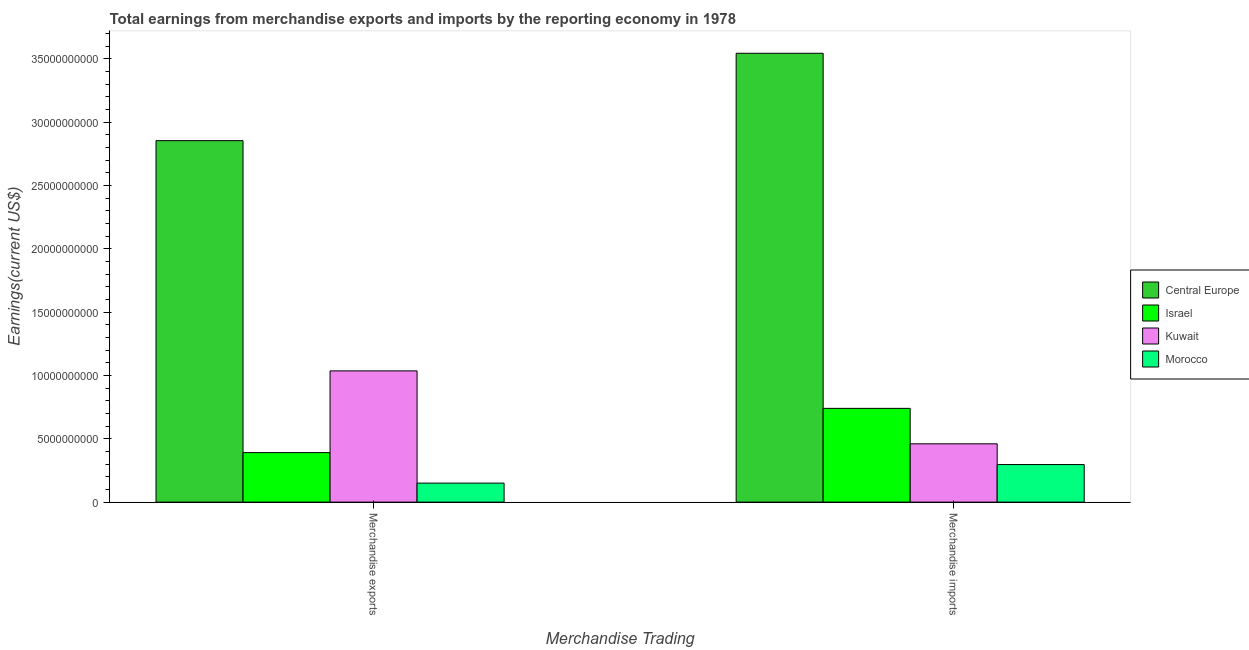What is the label of the 2nd group of bars from the left?
Your answer should be very brief. Merchandise imports. What is the earnings from merchandise exports in Morocco?
Your answer should be compact. 1.50e+09. Across all countries, what is the maximum earnings from merchandise imports?
Your response must be concise. 3.54e+1. Across all countries, what is the minimum earnings from merchandise imports?
Offer a very short reply. 2.97e+09. In which country was the earnings from merchandise exports maximum?
Make the answer very short. Central Europe. In which country was the earnings from merchandise imports minimum?
Ensure brevity in your answer.  Morocco. What is the total earnings from merchandise exports in the graph?
Your answer should be compact. 4.43e+1. What is the difference between the earnings from merchandise imports in Morocco and that in Kuwait?
Provide a succinct answer. -1.64e+09. What is the difference between the earnings from merchandise exports in Israel and the earnings from merchandise imports in Morocco?
Provide a short and direct response. 9.44e+08. What is the average earnings from merchandise imports per country?
Keep it short and to the point. 1.26e+1. What is the difference between the earnings from merchandise imports and earnings from merchandise exports in Israel?
Keep it short and to the point. 3.49e+09. What is the ratio of the earnings from merchandise exports in Israel to that in Kuwait?
Offer a terse response. 0.38. Is the earnings from merchandise exports in Israel less than that in Morocco?
Ensure brevity in your answer.  No. What does the 1st bar from the left in Merchandise imports represents?
Your answer should be very brief. Central Europe. What does the 2nd bar from the right in Merchandise exports represents?
Your answer should be compact. Kuwait. How many bars are there?
Your response must be concise. 8. How many countries are there in the graph?
Provide a short and direct response. 4. What is the difference between two consecutive major ticks on the Y-axis?
Provide a succinct answer. 5.00e+09. Are the values on the major ticks of Y-axis written in scientific E-notation?
Provide a short and direct response. No. Where does the legend appear in the graph?
Give a very brief answer. Center right. How many legend labels are there?
Make the answer very short. 4. What is the title of the graph?
Offer a very short reply. Total earnings from merchandise exports and imports by the reporting economy in 1978. Does "Ireland" appear as one of the legend labels in the graph?
Your answer should be very brief. No. What is the label or title of the X-axis?
Keep it short and to the point. Merchandise Trading. What is the label or title of the Y-axis?
Offer a very short reply. Earnings(current US$). What is the Earnings(current US$) in Central Europe in Merchandise exports?
Make the answer very short. 2.85e+1. What is the Earnings(current US$) of Israel in Merchandise exports?
Your response must be concise. 3.91e+09. What is the Earnings(current US$) of Kuwait in Merchandise exports?
Your response must be concise. 1.04e+1. What is the Earnings(current US$) of Morocco in Merchandise exports?
Your answer should be very brief. 1.50e+09. What is the Earnings(current US$) of Central Europe in Merchandise imports?
Your answer should be compact. 3.54e+1. What is the Earnings(current US$) of Israel in Merchandise imports?
Offer a terse response. 7.40e+09. What is the Earnings(current US$) of Kuwait in Merchandise imports?
Give a very brief answer. 4.60e+09. What is the Earnings(current US$) of Morocco in Merchandise imports?
Give a very brief answer. 2.97e+09. Across all Merchandise Trading, what is the maximum Earnings(current US$) in Central Europe?
Your answer should be compact. 3.54e+1. Across all Merchandise Trading, what is the maximum Earnings(current US$) of Israel?
Offer a terse response. 7.40e+09. Across all Merchandise Trading, what is the maximum Earnings(current US$) in Kuwait?
Your response must be concise. 1.04e+1. Across all Merchandise Trading, what is the maximum Earnings(current US$) of Morocco?
Your response must be concise. 2.97e+09. Across all Merchandise Trading, what is the minimum Earnings(current US$) in Central Europe?
Your answer should be compact. 2.85e+1. Across all Merchandise Trading, what is the minimum Earnings(current US$) in Israel?
Give a very brief answer. 3.91e+09. Across all Merchandise Trading, what is the minimum Earnings(current US$) in Kuwait?
Provide a short and direct response. 4.60e+09. Across all Merchandise Trading, what is the minimum Earnings(current US$) of Morocco?
Make the answer very short. 1.50e+09. What is the total Earnings(current US$) in Central Europe in the graph?
Offer a terse response. 6.40e+1. What is the total Earnings(current US$) in Israel in the graph?
Your response must be concise. 1.13e+1. What is the total Earnings(current US$) of Kuwait in the graph?
Keep it short and to the point. 1.50e+1. What is the total Earnings(current US$) in Morocco in the graph?
Offer a terse response. 4.47e+09. What is the difference between the Earnings(current US$) in Central Europe in Merchandise exports and that in Merchandise imports?
Provide a short and direct response. -6.90e+09. What is the difference between the Earnings(current US$) in Israel in Merchandise exports and that in Merchandise imports?
Offer a very short reply. -3.49e+09. What is the difference between the Earnings(current US$) in Kuwait in Merchandise exports and that in Merchandise imports?
Keep it short and to the point. 5.76e+09. What is the difference between the Earnings(current US$) in Morocco in Merchandise exports and that in Merchandise imports?
Provide a succinct answer. -1.47e+09. What is the difference between the Earnings(current US$) in Central Europe in Merchandise exports and the Earnings(current US$) in Israel in Merchandise imports?
Make the answer very short. 2.11e+1. What is the difference between the Earnings(current US$) of Central Europe in Merchandise exports and the Earnings(current US$) of Kuwait in Merchandise imports?
Offer a terse response. 2.39e+1. What is the difference between the Earnings(current US$) of Central Europe in Merchandise exports and the Earnings(current US$) of Morocco in Merchandise imports?
Your answer should be very brief. 2.56e+1. What is the difference between the Earnings(current US$) in Israel in Merchandise exports and the Earnings(current US$) in Kuwait in Merchandise imports?
Offer a terse response. -6.93e+08. What is the difference between the Earnings(current US$) of Israel in Merchandise exports and the Earnings(current US$) of Morocco in Merchandise imports?
Give a very brief answer. 9.44e+08. What is the difference between the Earnings(current US$) in Kuwait in Merchandise exports and the Earnings(current US$) in Morocco in Merchandise imports?
Offer a terse response. 7.40e+09. What is the average Earnings(current US$) in Central Europe per Merchandise Trading?
Your answer should be very brief. 3.20e+1. What is the average Earnings(current US$) of Israel per Merchandise Trading?
Your response must be concise. 5.66e+09. What is the average Earnings(current US$) of Kuwait per Merchandise Trading?
Offer a very short reply. 7.48e+09. What is the average Earnings(current US$) of Morocco per Merchandise Trading?
Your answer should be very brief. 2.23e+09. What is the difference between the Earnings(current US$) in Central Europe and Earnings(current US$) in Israel in Merchandise exports?
Your response must be concise. 2.46e+1. What is the difference between the Earnings(current US$) in Central Europe and Earnings(current US$) in Kuwait in Merchandise exports?
Offer a very short reply. 1.82e+1. What is the difference between the Earnings(current US$) in Central Europe and Earnings(current US$) in Morocco in Merchandise exports?
Make the answer very short. 2.70e+1. What is the difference between the Earnings(current US$) of Israel and Earnings(current US$) of Kuwait in Merchandise exports?
Make the answer very short. -6.45e+09. What is the difference between the Earnings(current US$) of Israel and Earnings(current US$) of Morocco in Merchandise exports?
Keep it short and to the point. 2.41e+09. What is the difference between the Earnings(current US$) of Kuwait and Earnings(current US$) of Morocco in Merchandise exports?
Make the answer very short. 8.86e+09. What is the difference between the Earnings(current US$) of Central Europe and Earnings(current US$) of Israel in Merchandise imports?
Provide a short and direct response. 2.80e+1. What is the difference between the Earnings(current US$) in Central Europe and Earnings(current US$) in Kuwait in Merchandise imports?
Ensure brevity in your answer.  3.08e+1. What is the difference between the Earnings(current US$) of Central Europe and Earnings(current US$) of Morocco in Merchandise imports?
Offer a very short reply. 3.25e+1. What is the difference between the Earnings(current US$) in Israel and Earnings(current US$) in Kuwait in Merchandise imports?
Your answer should be very brief. 2.80e+09. What is the difference between the Earnings(current US$) of Israel and Earnings(current US$) of Morocco in Merchandise imports?
Keep it short and to the point. 4.44e+09. What is the difference between the Earnings(current US$) of Kuwait and Earnings(current US$) of Morocco in Merchandise imports?
Your answer should be compact. 1.64e+09. What is the ratio of the Earnings(current US$) in Central Europe in Merchandise exports to that in Merchandise imports?
Give a very brief answer. 0.81. What is the ratio of the Earnings(current US$) of Israel in Merchandise exports to that in Merchandise imports?
Keep it short and to the point. 0.53. What is the ratio of the Earnings(current US$) in Kuwait in Merchandise exports to that in Merchandise imports?
Ensure brevity in your answer.  2.25. What is the ratio of the Earnings(current US$) in Morocco in Merchandise exports to that in Merchandise imports?
Your answer should be very brief. 0.51. What is the difference between the highest and the second highest Earnings(current US$) in Central Europe?
Your answer should be very brief. 6.90e+09. What is the difference between the highest and the second highest Earnings(current US$) of Israel?
Ensure brevity in your answer.  3.49e+09. What is the difference between the highest and the second highest Earnings(current US$) of Kuwait?
Give a very brief answer. 5.76e+09. What is the difference between the highest and the second highest Earnings(current US$) in Morocco?
Give a very brief answer. 1.47e+09. What is the difference between the highest and the lowest Earnings(current US$) of Central Europe?
Provide a succinct answer. 6.90e+09. What is the difference between the highest and the lowest Earnings(current US$) of Israel?
Offer a terse response. 3.49e+09. What is the difference between the highest and the lowest Earnings(current US$) in Kuwait?
Your response must be concise. 5.76e+09. What is the difference between the highest and the lowest Earnings(current US$) of Morocco?
Provide a short and direct response. 1.47e+09. 